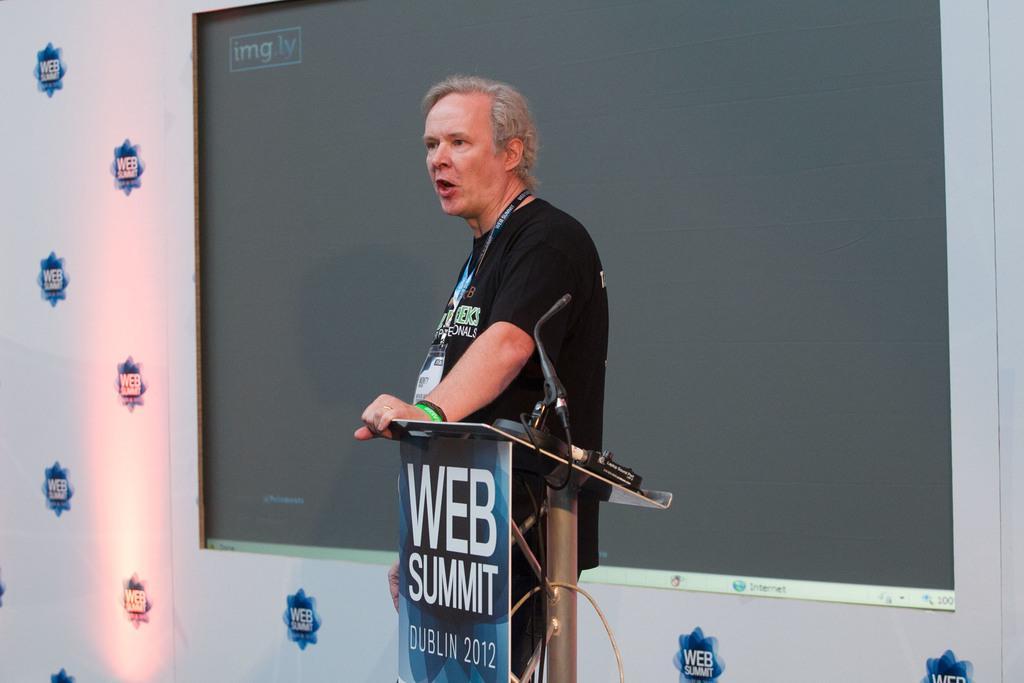How would you summarize this image in a sentence or two? In the center of the image we can see one person is standing. In front of him, we can see one stand, one microphone, banner and a few other objects. On the banner, we can see some text. In the background there is a screen and one banner. And we can see some text on the banner and on the screen. 